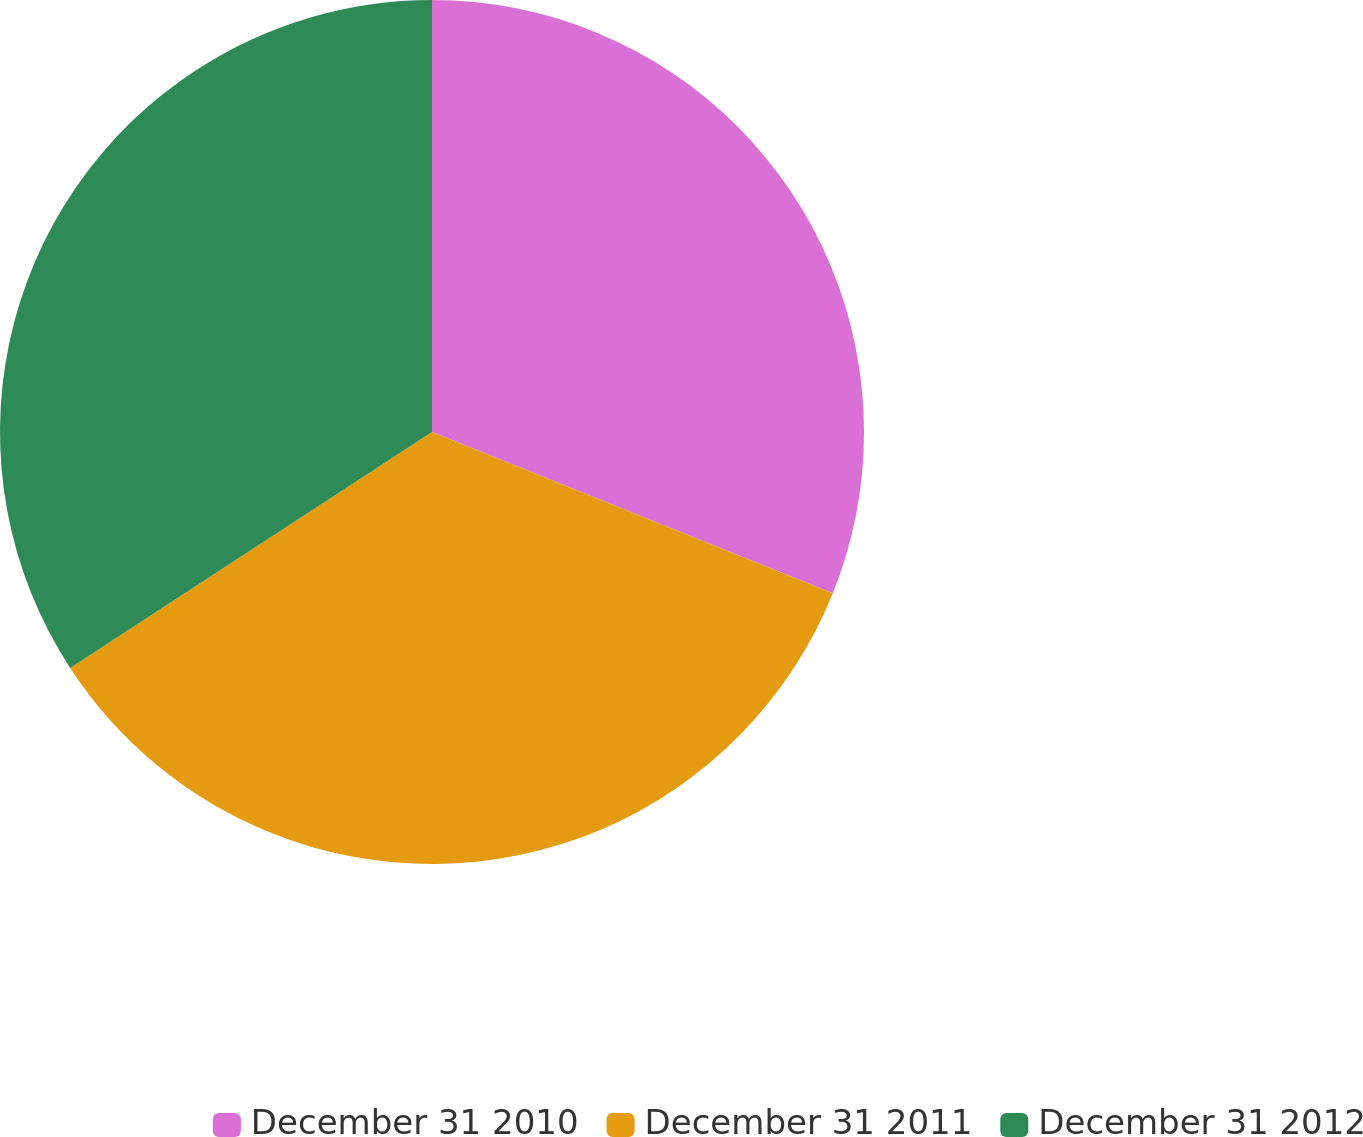Convert chart to OTSL. <chart><loc_0><loc_0><loc_500><loc_500><pie_chart><fcel>December 31 2010<fcel>December 31 2011<fcel>December 31 2012<nl><fcel>31.09%<fcel>34.72%<fcel>34.2%<nl></chart> 